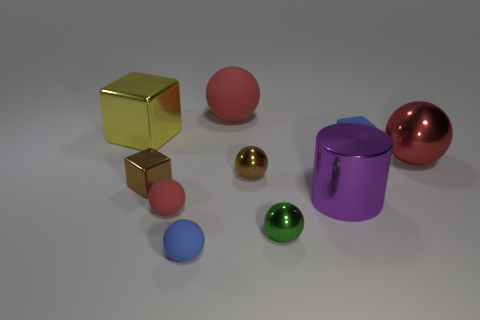Subtract all red balls. How many were subtracted if there are1red balls left? 2 Subtract all red cubes. How many red balls are left? 3 Subtract all blue spheres. How many spheres are left? 5 Subtract all small brown shiny balls. How many balls are left? 5 Subtract 3 spheres. How many spheres are left? 3 Subtract all gray balls. Subtract all purple cylinders. How many balls are left? 6 Subtract all blocks. How many objects are left? 7 Add 8 yellow objects. How many yellow objects exist? 9 Subtract 1 red spheres. How many objects are left? 9 Subtract all big red metal spheres. Subtract all red metallic objects. How many objects are left? 8 